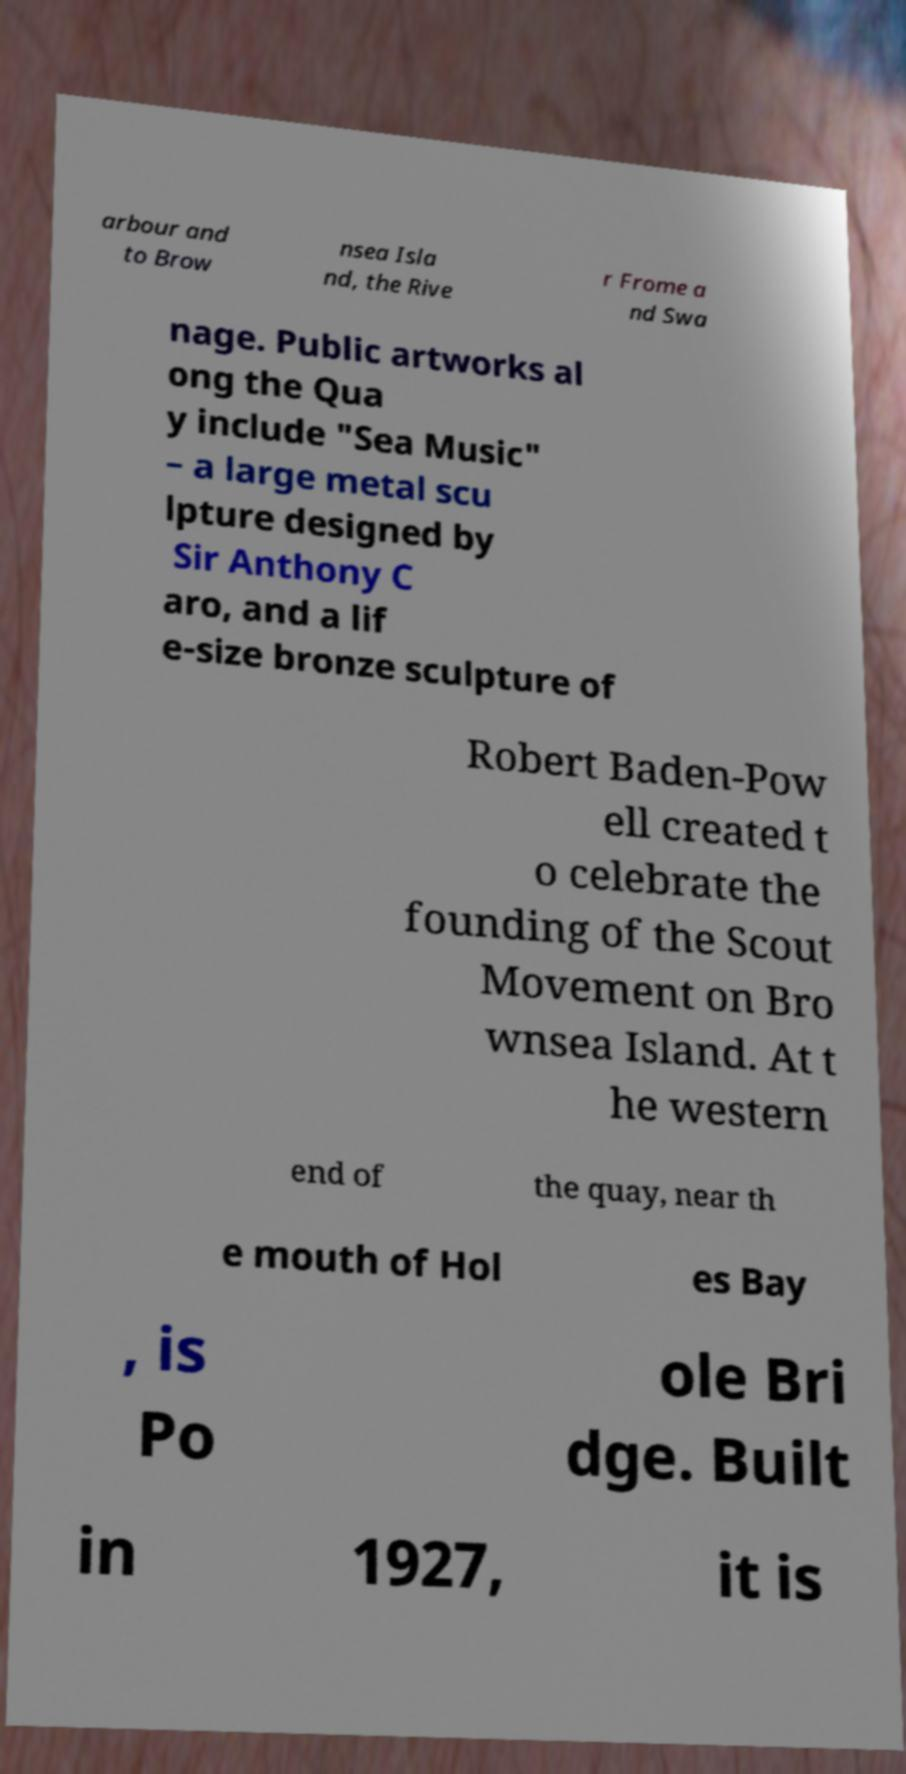Please read and relay the text visible in this image. What does it say? arbour and to Brow nsea Isla nd, the Rive r Frome a nd Swa nage. Public artworks al ong the Qua y include "Sea Music" – a large metal scu lpture designed by Sir Anthony C aro, and a lif e-size bronze sculpture of Robert Baden-Pow ell created t o celebrate the founding of the Scout Movement on Bro wnsea Island. At t he western end of the quay, near th e mouth of Hol es Bay , is Po ole Bri dge. Built in 1927, it is 